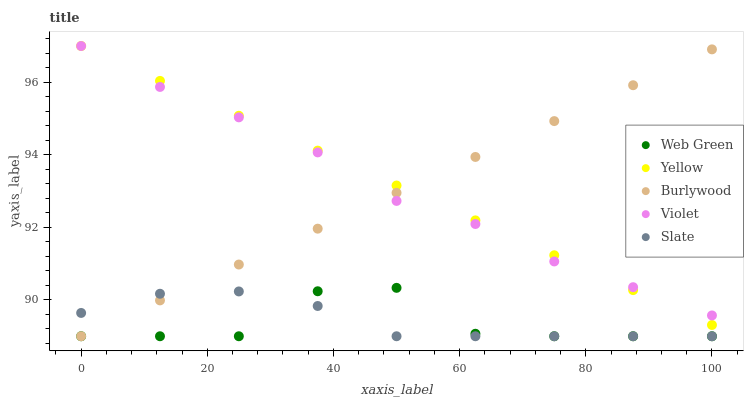Does Web Green have the minimum area under the curve?
Answer yes or no. Yes. Does Yellow have the maximum area under the curve?
Answer yes or no. Yes. Does Slate have the minimum area under the curve?
Answer yes or no. No. Does Slate have the maximum area under the curve?
Answer yes or no. No. Is Burlywood the smoothest?
Answer yes or no. Yes. Is Web Green the roughest?
Answer yes or no. Yes. Is Slate the smoothest?
Answer yes or no. No. Is Slate the roughest?
Answer yes or no. No. Does Burlywood have the lowest value?
Answer yes or no. Yes. Does Yellow have the lowest value?
Answer yes or no. No. Does Violet have the highest value?
Answer yes or no. Yes. Does Slate have the highest value?
Answer yes or no. No. Is Web Green less than Violet?
Answer yes or no. Yes. Is Violet greater than Web Green?
Answer yes or no. Yes. Does Web Green intersect Burlywood?
Answer yes or no. Yes. Is Web Green less than Burlywood?
Answer yes or no. No. Is Web Green greater than Burlywood?
Answer yes or no. No. Does Web Green intersect Violet?
Answer yes or no. No. 